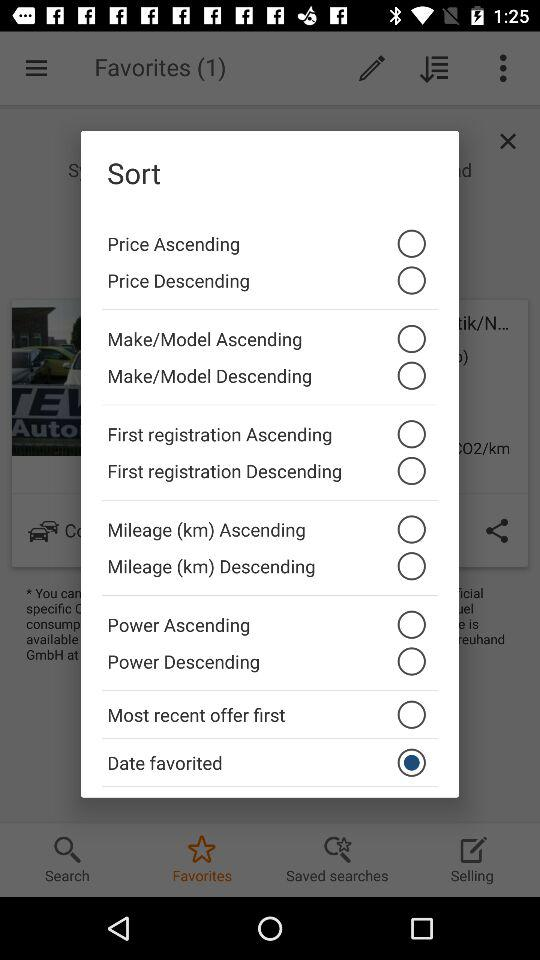Which option is selected? The selected option is "Date favorited". 